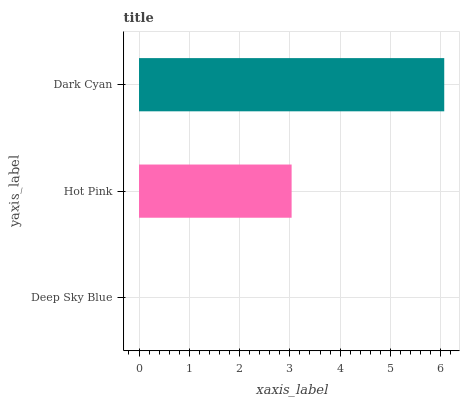Is Deep Sky Blue the minimum?
Answer yes or no. Yes. Is Dark Cyan the maximum?
Answer yes or no. Yes. Is Hot Pink the minimum?
Answer yes or no. No. Is Hot Pink the maximum?
Answer yes or no. No. Is Hot Pink greater than Deep Sky Blue?
Answer yes or no. Yes. Is Deep Sky Blue less than Hot Pink?
Answer yes or no. Yes. Is Deep Sky Blue greater than Hot Pink?
Answer yes or no. No. Is Hot Pink less than Deep Sky Blue?
Answer yes or no. No. Is Hot Pink the high median?
Answer yes or no. Yes. Is Hot Pink the low median?
Answer yes or no. Yes. Is Dark Cyan the high median?
Answer yes or no. No. Is Deep Sky Blue the low median?
Answer yes or no. No. 